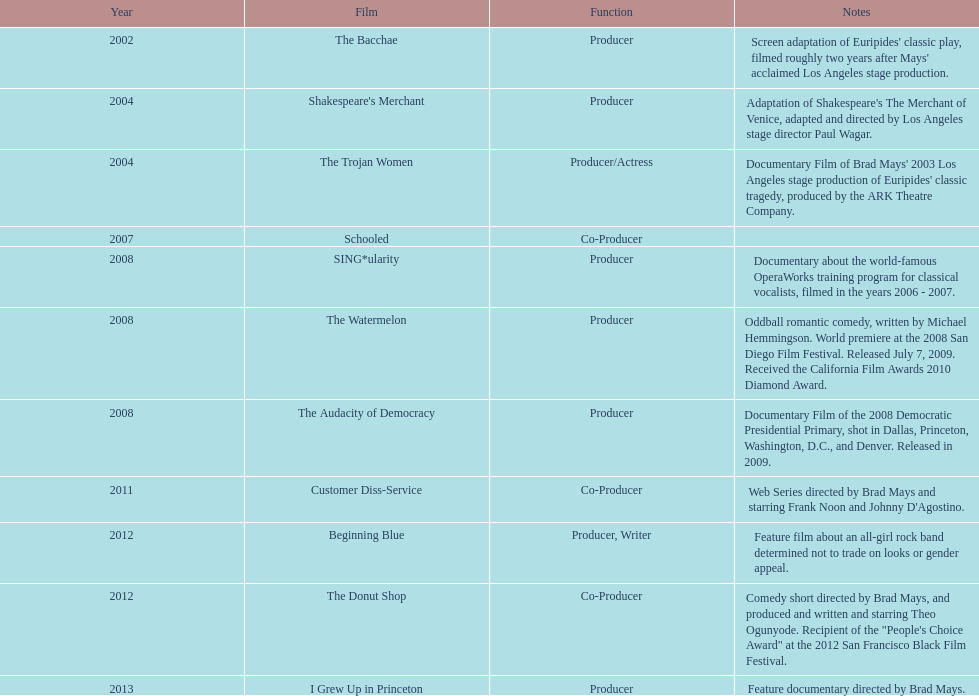In what year did ms. starfelt produce the maximum number of motion pictures? 2008. 